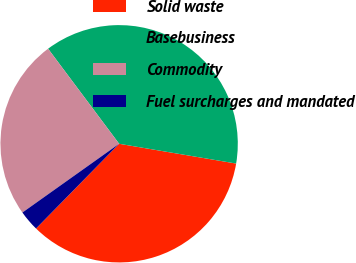Convert chart. <chart><loc_0><loc_0><loc_500><loc_500><pie_chart><fcel>Solid waste<fcel>Basebusiness<fcel>Commodity<fcel>Fuel surcharges and mandated<nl><fcel>34.68%<fcel>37.88%<fcel>24.62%<fcel>2.82%<nl></chart> 